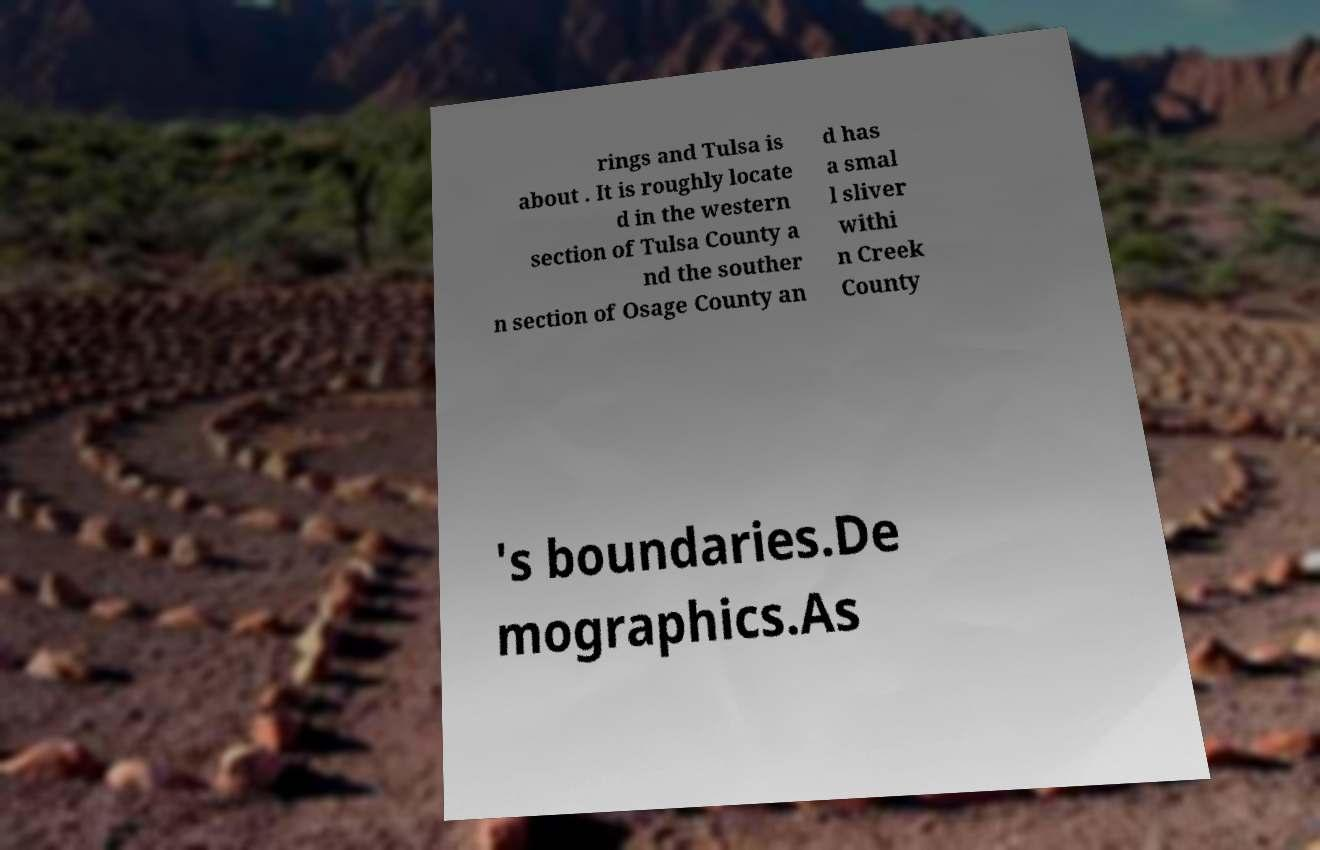I need the written content from this picture converted into text. Can you do that? rings and Tulsa is about . It is roughly locate d in the western section of Tulsa County a nd the souther n section of Osage County an d has a smal l sliver withi n Creek County 's boundaries.De mographics.As 